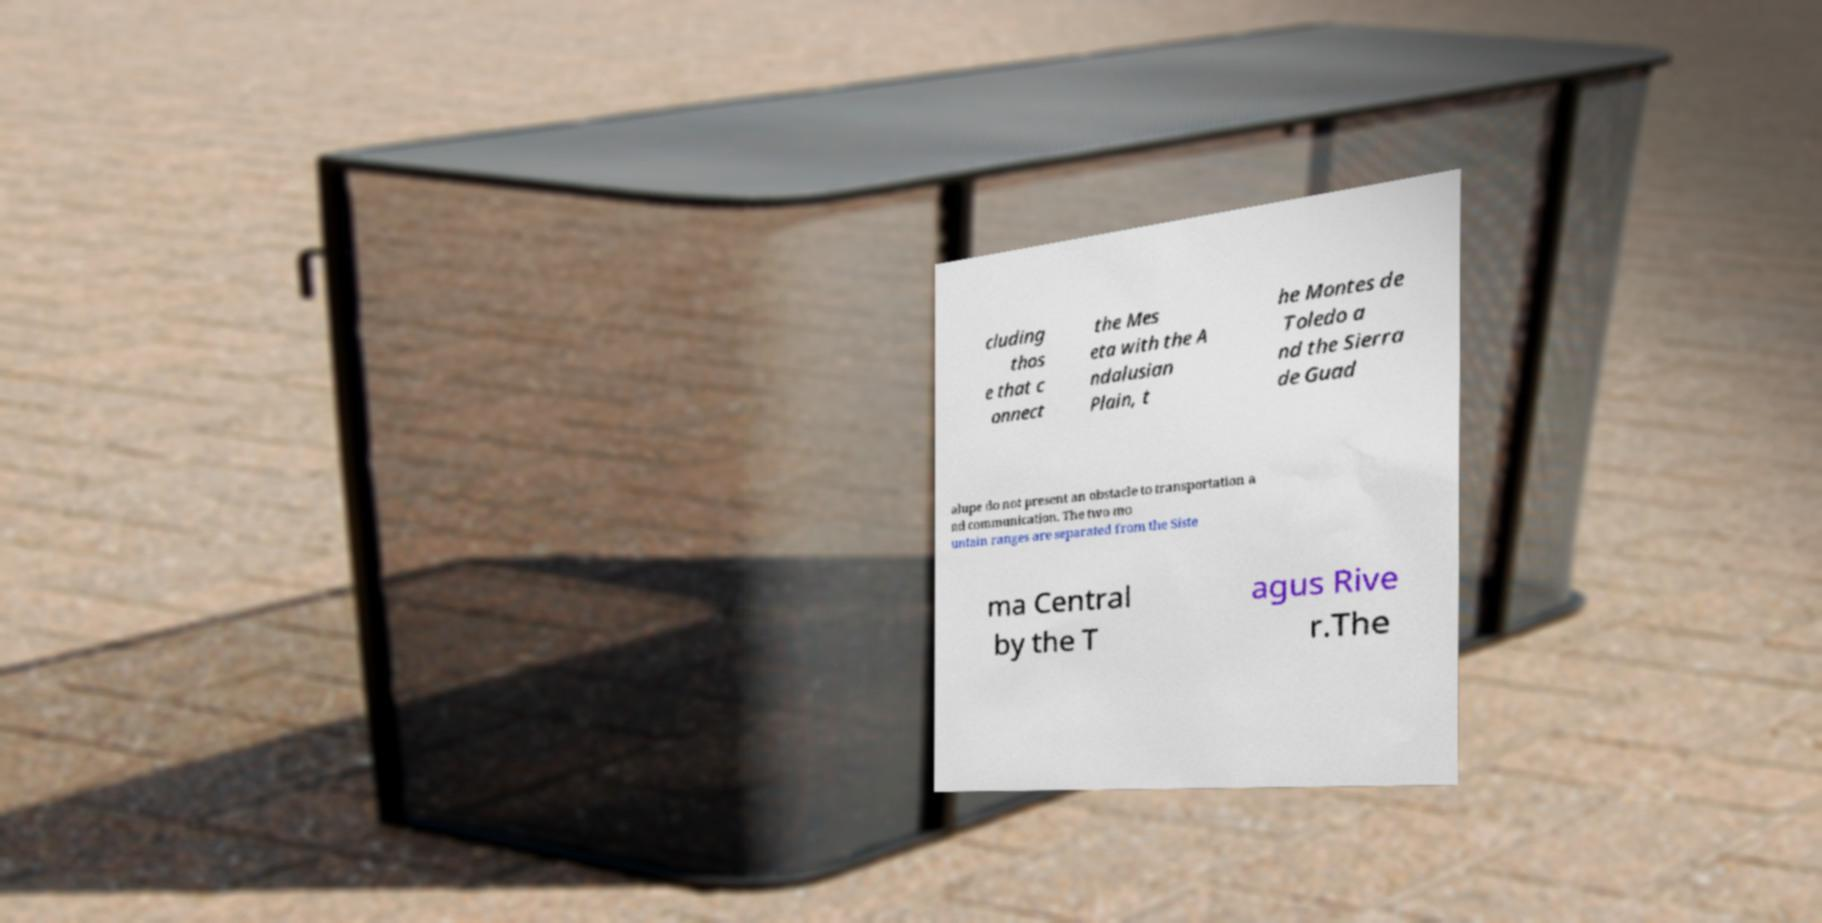What messages or text are displayed in this image? I need them in a readable, typed format. cluding thos e that c onnect the Mes eta with the A ndalusian Plain, t he Montes de Toledo a nd the Sierra de Guad alupe do not present an obstacle to transportation a nd communication. The two mo untain ranges are separated from the Siste ma Central by the T agus Rive r.The 